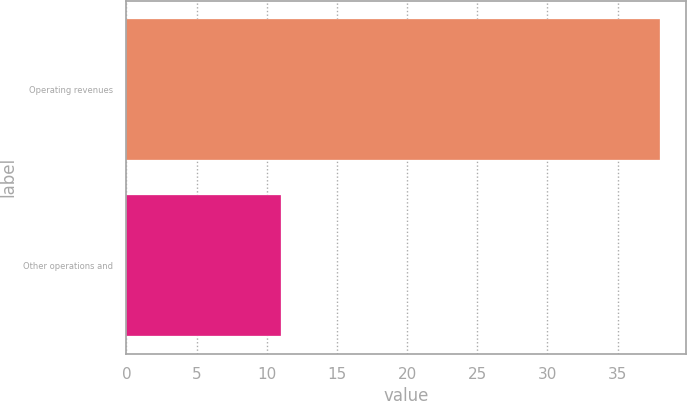Convert chart to OTSL. <chart><loc_0><loc_0><loc_500><loc_500><bar_chart><fcel>Operating revenues<fcel>Other operations and<nl><fcel>38<fcel>11<nl></chart> 